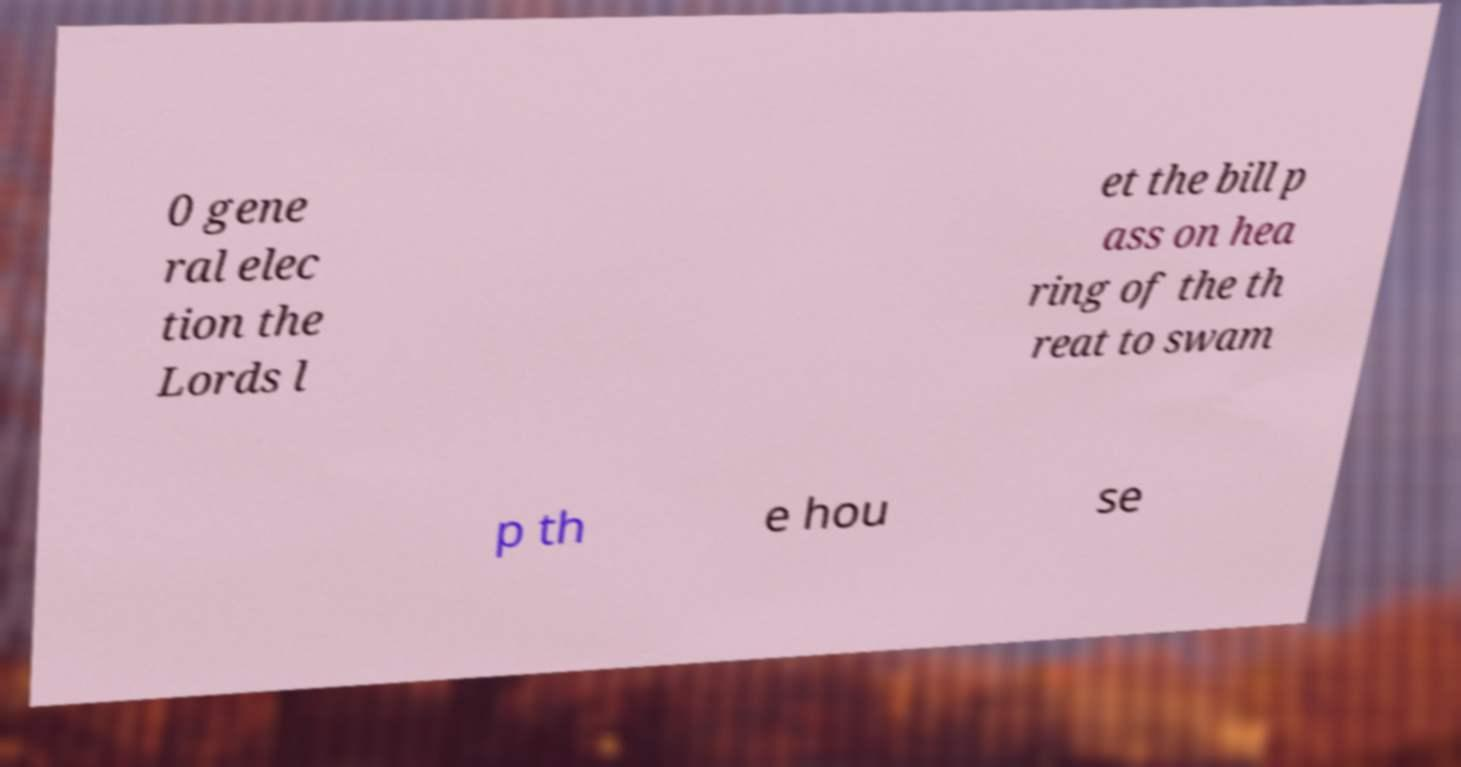Could you extract and type out the text from this image? 0 gene ral elec tion the Lords l et the bill p ass on hea ring of the th reat to swam p th e hou se 